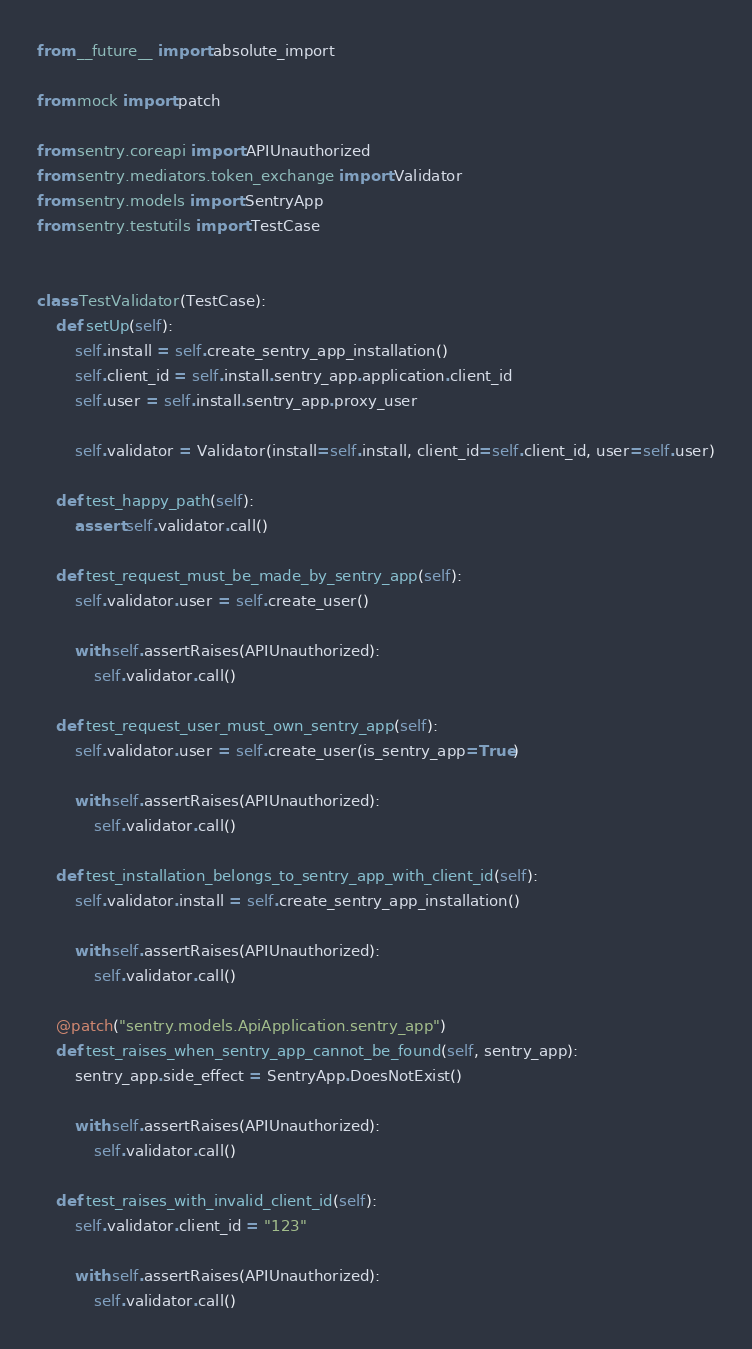<code> <loc_0><loc_0><loc_500><loc_500><_Python_>from __future__ import absolute_import

from mock import patch

from sentry.coreapi import APIUnauthorized
from sentry.mediators.token_exchange import Validator
from sentry.models import SentryApp
from sentry.testutils import TestCase


class TestValidator(TestCase):
    def setUp(self):
        self.install = self.create_sentry_app_installation()
        self.client_id = self.install.sentry_app.application.client_id
        self.user = self.install.sentry_app.proxy_user

        self.validator = Validator(install=self.install, client_id=self.client_id, user=self.user)

    def test_happy_path(self):
        assert self.validator.call()

    def test_request_must_be_made_by_sentry_app(self):
        self.validator.user = self.create_user()

        with self.assertRaises(APIUnauthorized):
            self.validator.call()

    def test_request_user_must_own_sentry_app(self):
        self.validator.user = self.create_user(is_sentry_app=True)

        with self.assertRaises(APIUnauthorized):
            self.validator.call()

    def test_installation_belongs_to_sentry_app_with_client_id(self):
        self.validator.install = self.create_sentry_app_installation()

        with self.assertRaises(APIUnauthorized):
            self.validator.call()

    @patch("sentry.models.ApiApplication.sentry_app")
    def test_raises_when_sentry_app_cannot_be_found(self, sentry_app):
        sentry_app.side_effect = SentryApp.DoesNotExist()

        with self.assertRaises(APIUnauthorized):
            self.validator.call()

    def test_raises_with_invalid_client_id(self):
        self.validator.client_id = "123"

        with self.assertRaises(APIUnauthorized):
            self.validator.call()
</code> 